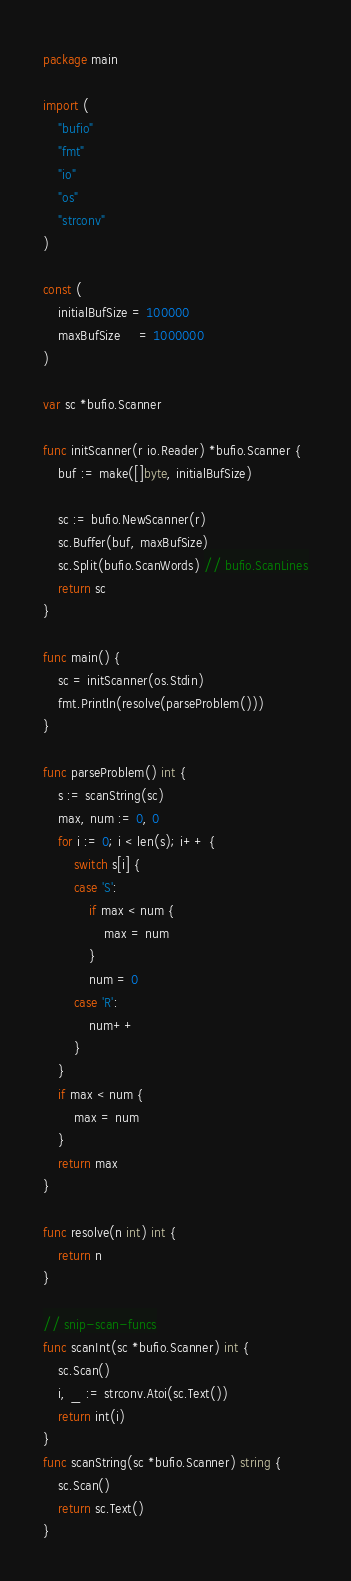Convert code to text. <code><loc_0><loc_0><loc_500><loc_500><_Go_>package main

import (
	"bufio"
	"fmt"
	"io"
	"os"
	"strconv"
)

const (
	initialBufSize = 100000
	maxBufSize     = 1000000
)

var sc *bufio.Scanner

func initScanner(r io.Reader) *bufio.Scanner {
	buf := make([]byte, initialBufSize)

	sc := bufio.NewScanner(r)
	sc.Buffer(buf, maxBufSize)
	sc.Split(bufio.ScanWords) // bufio.ScanLines
	return sc
}

func main() {
	sc = initScanner(os.Stdin)
	fmt.Println(resolve(parseProblem()))
}

func parseProblem() int {
	s := scanString(sc)
	max, num := 0, 0
	for i := 0; i < len(s); i++ {
		switch s[i] {
		case 'S':
			if max < num {
				max = num
			}
			num = 0
		case 'R':
			num++
		}
	}
	if max < num {
		max = num
	}
	return max
}

func resolve(n int) int {
	return n
}

// snip-scan-funcs
func scanInt(sc *bufio.Scanner) int {
	sc.Scan()
	i, _ := strconv.Atoi(sc.Text())
	return int(i)
}
func scanString(sc *bufio.Scanner) string {
	sc.Scan()
	return sc.Text()
}
</code> 